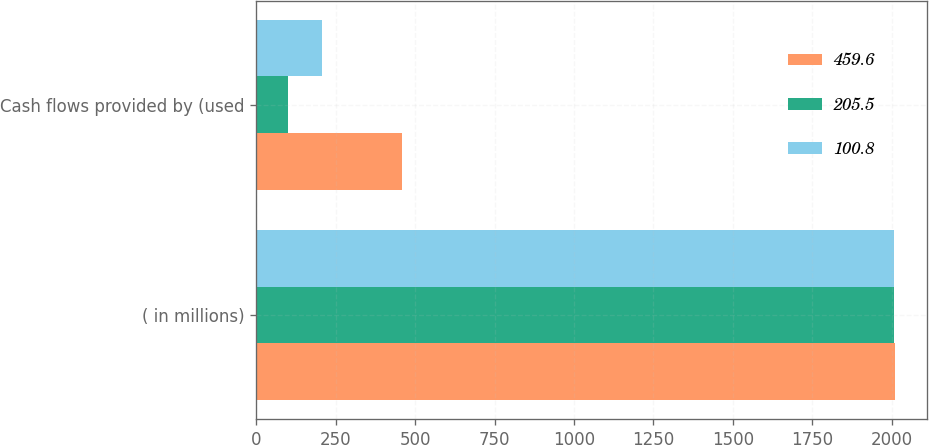Convert chart. <chart><loc_0><loc_0><loc_500><loc_500><stacked_bar_chart><ecel><fcel>( in millions)<fcel>Cash flows provided by (used<nl><fcel>459.6<fcel>2010<fcel>459.6<nl><fcel>205.5<fcel>2009<fcel>100.8<nl><fcel>100.8<fcel>2008<fcel>205.5<nl></chart> 